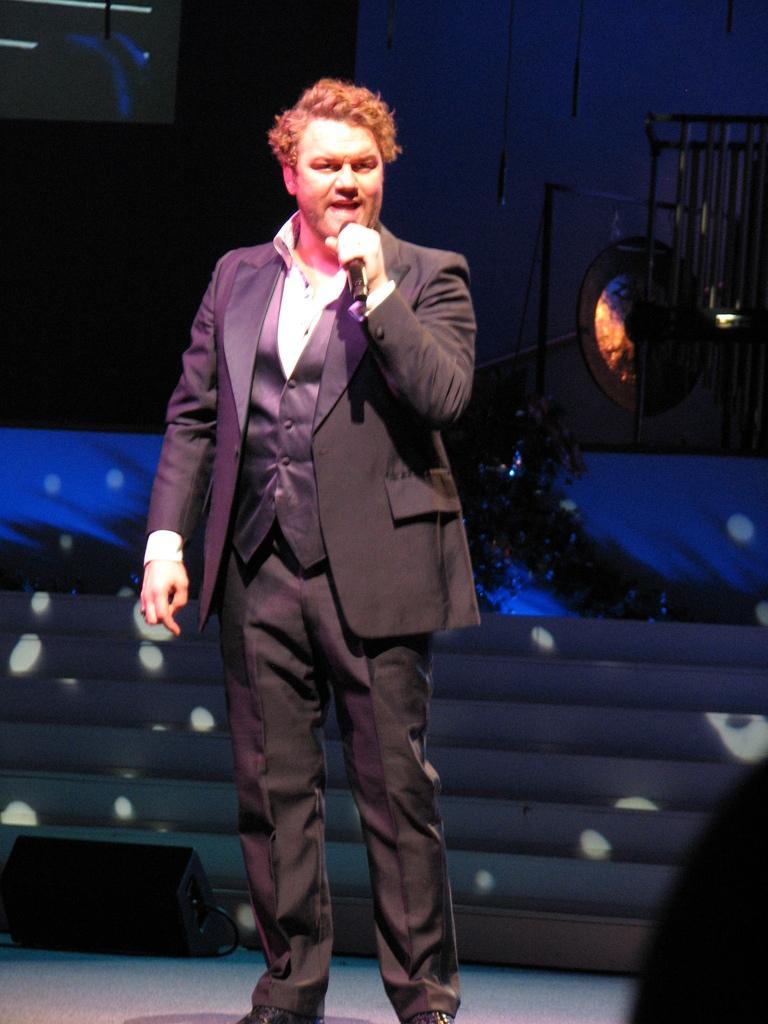Could you give a brief overview of what you see in this image? In this picture we can see a man standing and holding a microphone, this man is wearing a suit and he is speaking something, it looks like a cymbal in the background. 